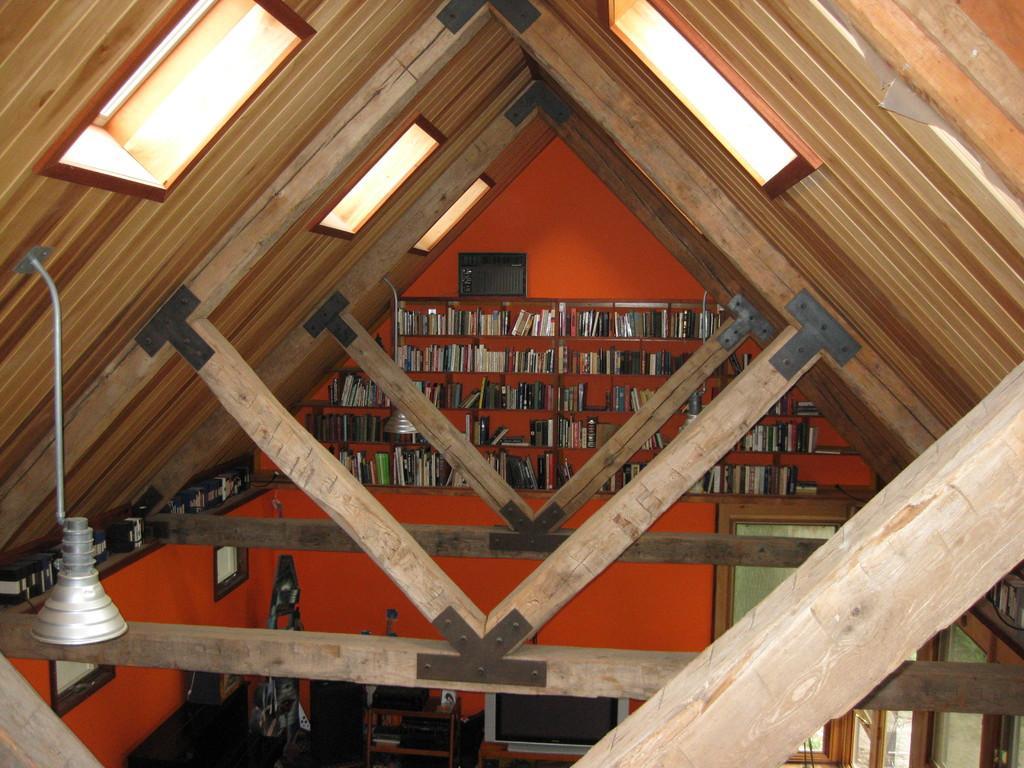In one or two sentences, can you explain what this image depicts? In this picture there is a beam in the center of the image and there is a bookshelf in the background area of the image. 